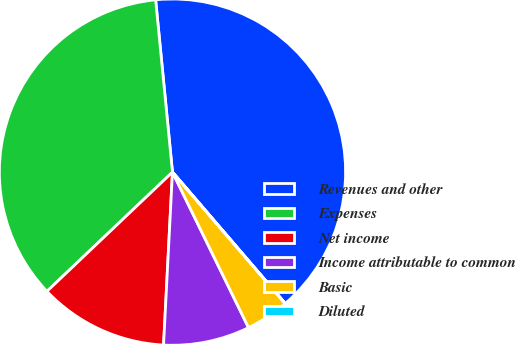Convert chart. <chart><loc_0><loc_0><loc_500><loc_500><pie_chart><fcel>Revenues and other<fcel>Expenses<fcel>Net income<fcel>Income attributable to common<fcel>Basic<fcel>Diluted<nl><fcel>40.26%<fcel>35.54%<fcel>12.09%<fcel>8.06%<fcel>4.04%<fcel>0.01%<nl></chart> 